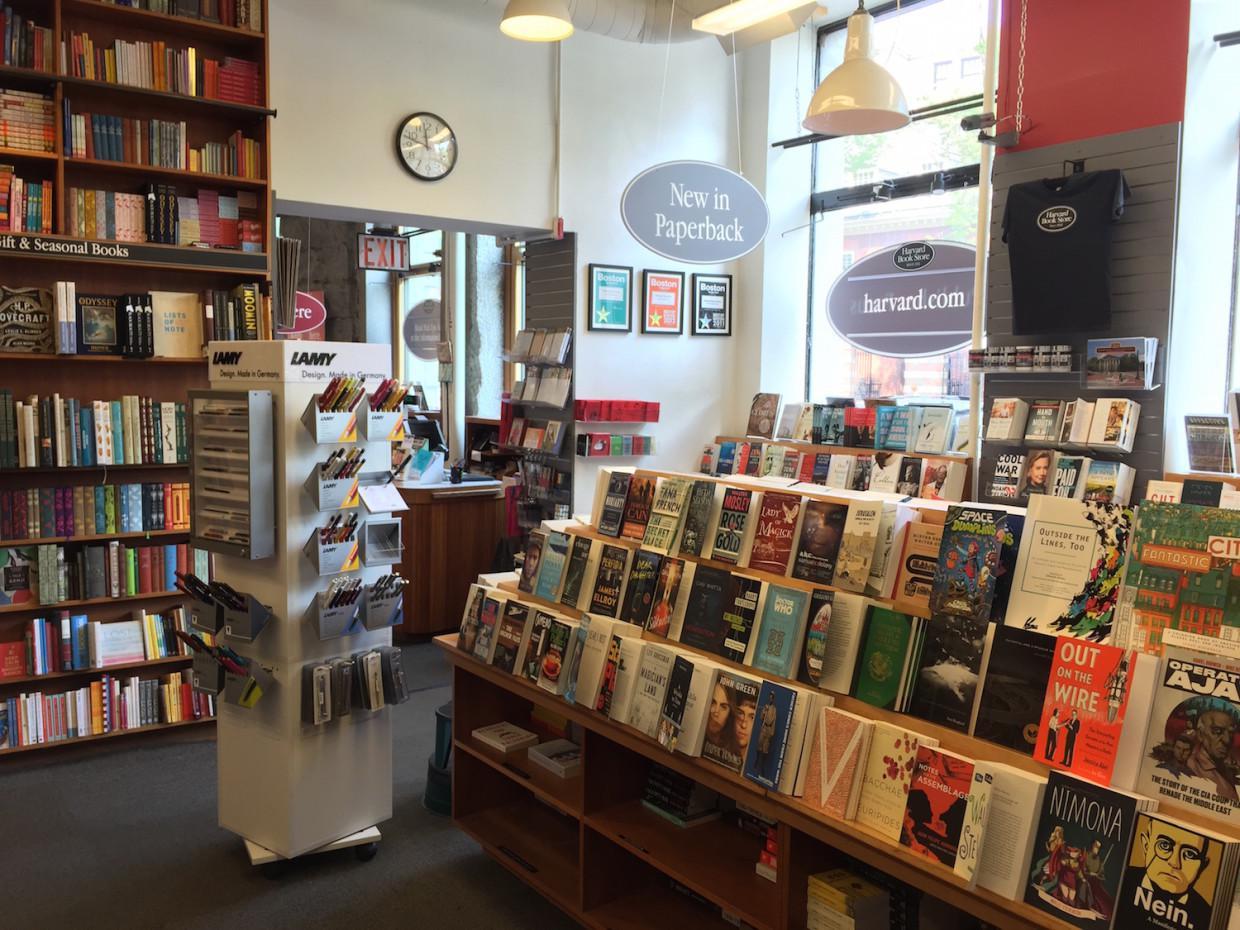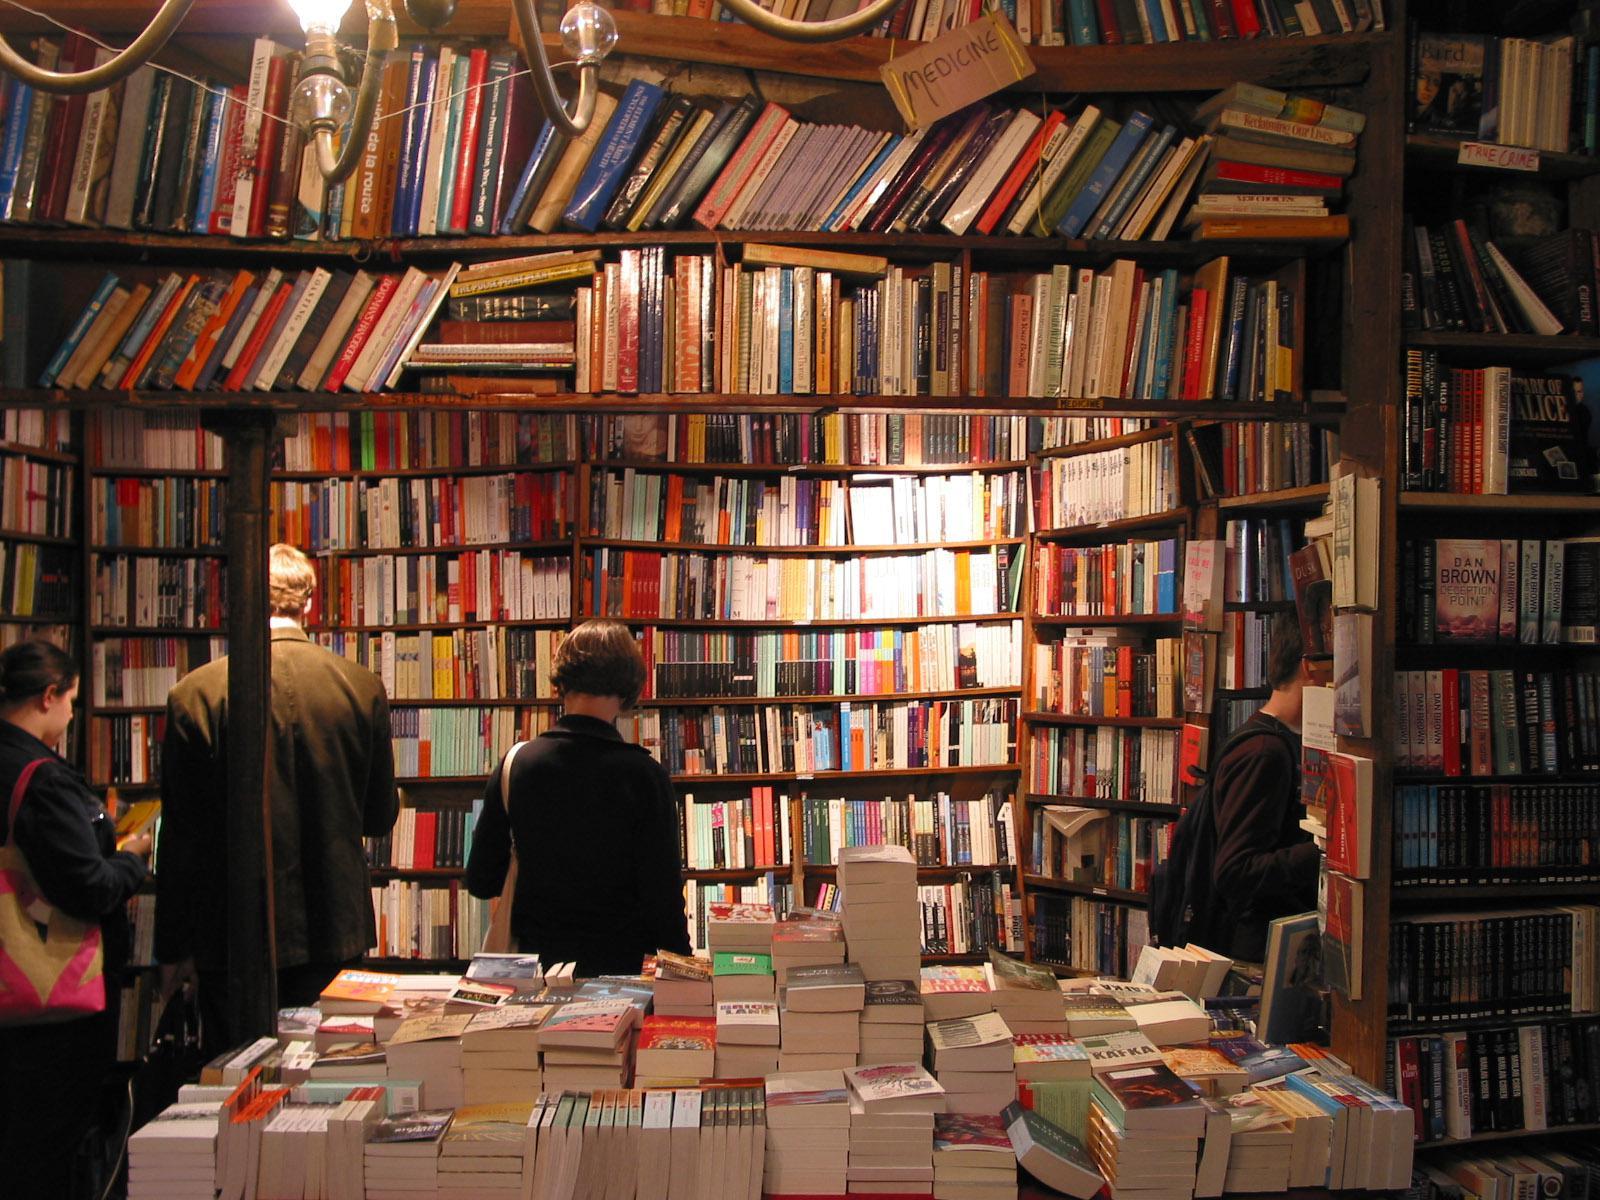The first image is the image on the left, the second image is the image on the right. Given the left and right images, does the statement "There are at least two people inside the store in the image on the right." hold true? Answer yes or no. Yes. 